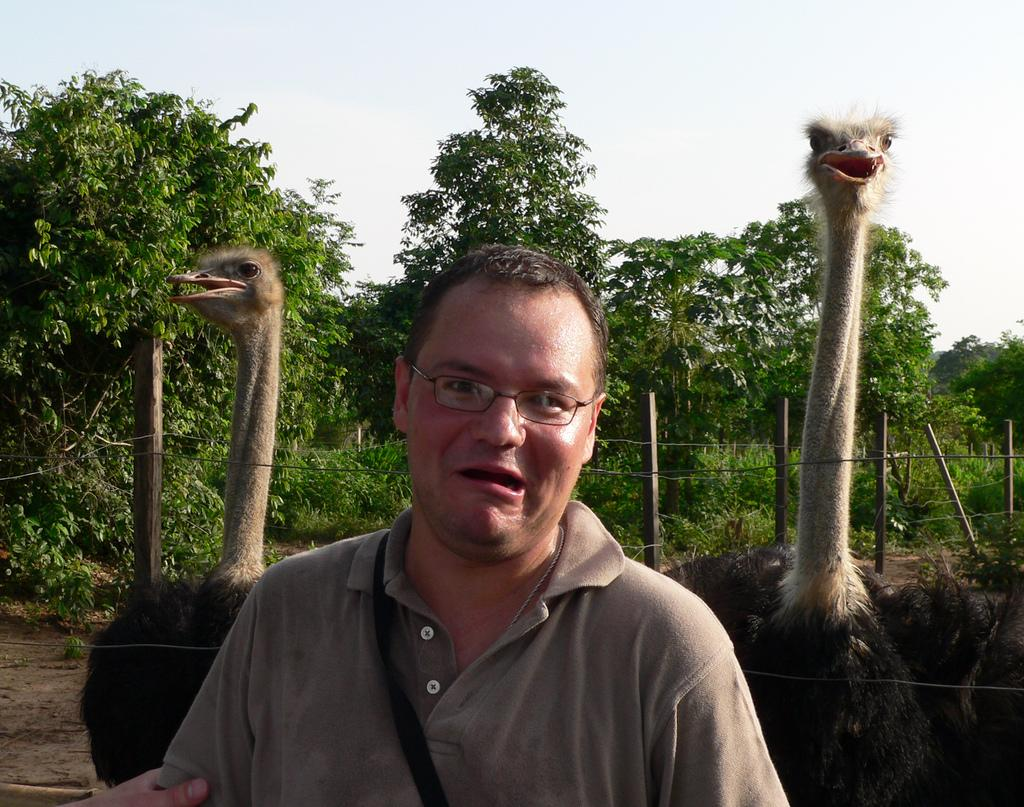What is the man in the image wearing on his face? The man is wearing glasses in the image. What type of animals are present in the image? There are ostriches in the image. What type of vegetation can be seen in the image? There are trees and plants in the image. What part of the natural environment is visible in the image? The sky is visible in the image. What type of teeth can be seen in the image? There are no teeth visible in the image, as it features a man wearing glasses and ostriches in a natural environment. How does the mist affect the visibility of the ostriches in the image? There is no mention of mist in the image, so it cannot be determined how it might affect the visibility of the ostriches. 